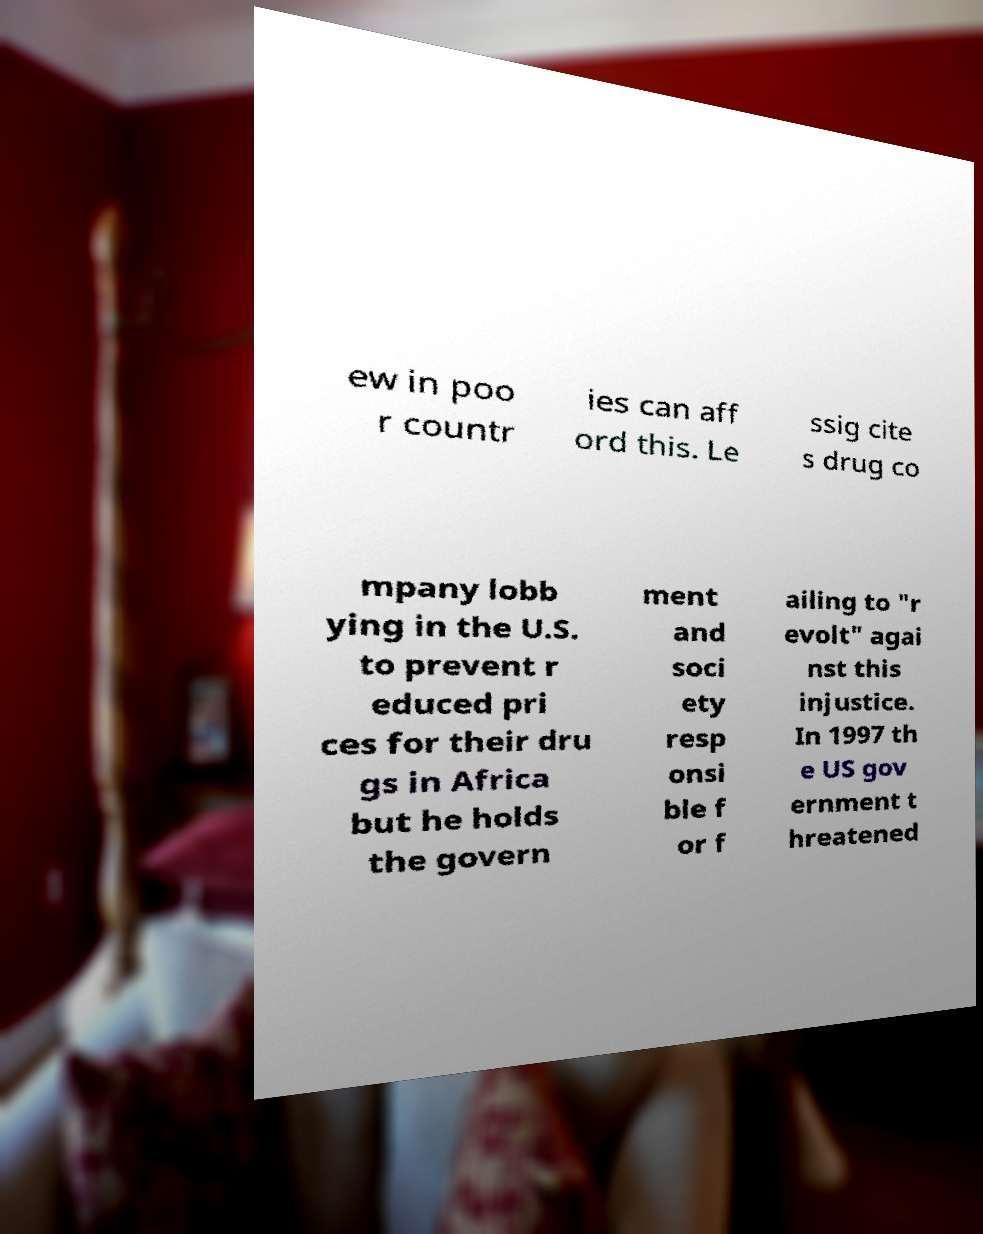There's text embedded in this image that I need extracted. Can you transcribe it verbatim? ew in poo r countr ies can aff ord this. Le ssig cite s drug co mpany lobb ying in the U.S. to prevent r educed pri ces for their dru gs in Africa but he holds the govern ment and soci ety resp onsi ble f or f ailing to "r evolt" agai nst this injustice. In 1997 th e US gov ernment t hreatened 